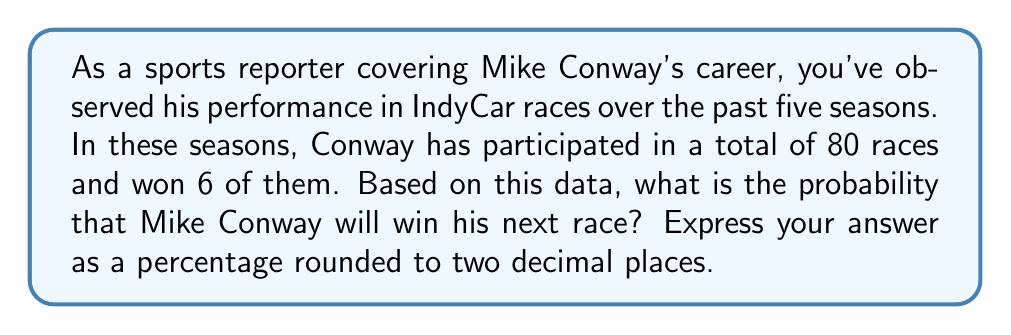Solve this math problem. To solve this probability problem, we'll use the concept of relative frequency as an estimate of probability. Here's the step-by-step explanation:

1. Identify the given information:
   - Total number of races: 80
   - Number of races won: 6

2. Calculate the probability using the formula:

   $$P(\text{winning}) = \frac{\text{Number of favorable outcomes}}{\text{Total number of outcomes}}$$

3. Plug in the values:

   $$P(\text{winning}) = \frac{6}{80}$$

4. Simplify the fraction:

   $$P(\text{winning}) = \frac{3}{40} = 0.075$$

5. Convert the probability to a percentage:

   $$0.075 \times 100\% = 7.50\%$$

6. Round to two decimal places:
   7.50% (already in the correct format)

Therefore, based on Mike Conway's past performance, the probability of him winning his next race is 7.50%.
Answer: 7.50% 